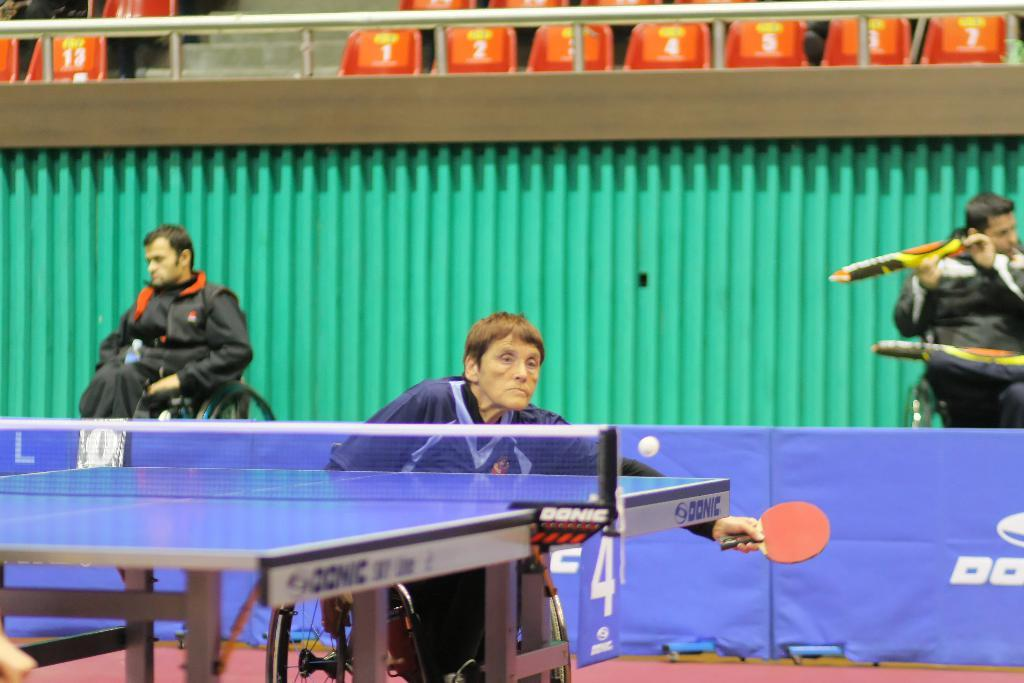What are the people in the image using to move around? The people in the image are seated on wheelchairs. Can you describe the woman in the image? The woman in the image is seated on a wheelchair. What activity is the woman in the image participating in? The woman in the image is playing table tennis. What emotion does the woman feel when she is ordered to stop playing table tennis in the image? There is no indication in the image that the woman is being ordered to stop playing table tennis, nor is there any information about her emotions. 